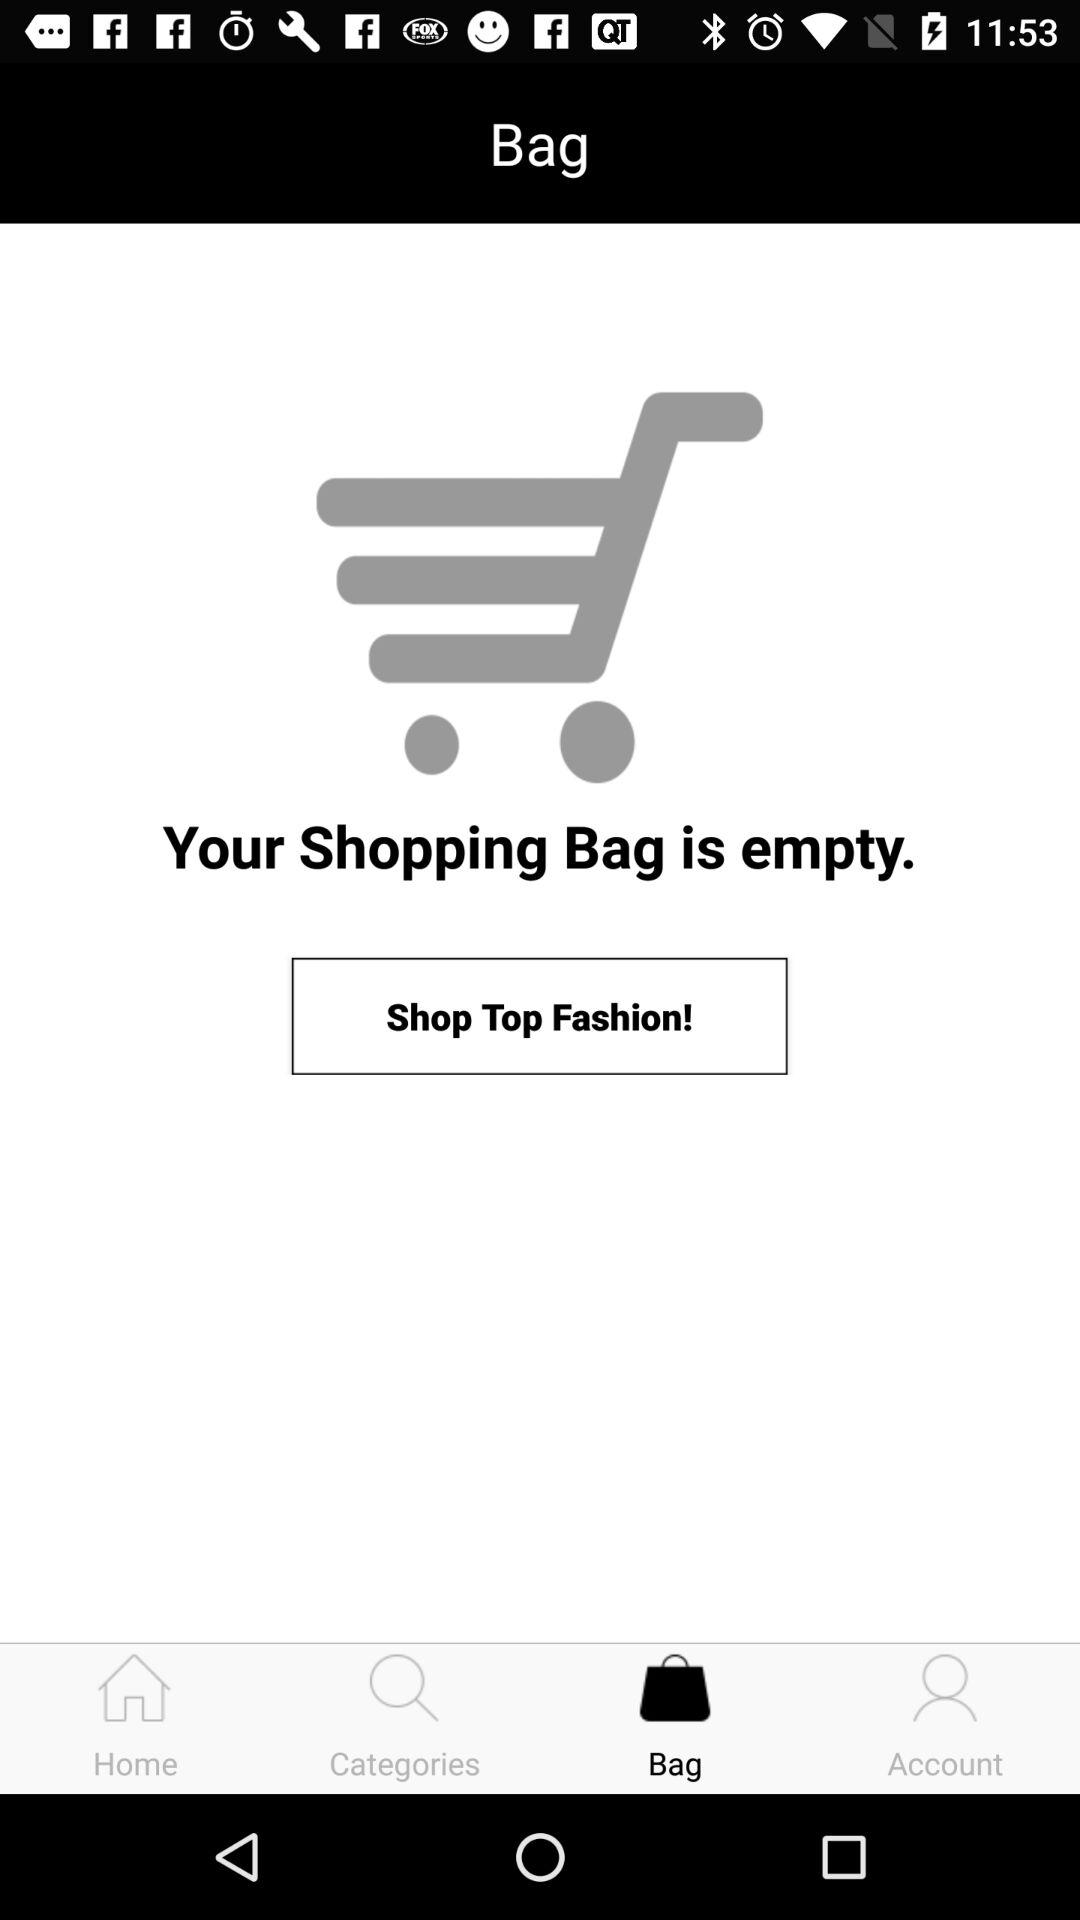Which tab is selected? The selected tab is "Bag". 